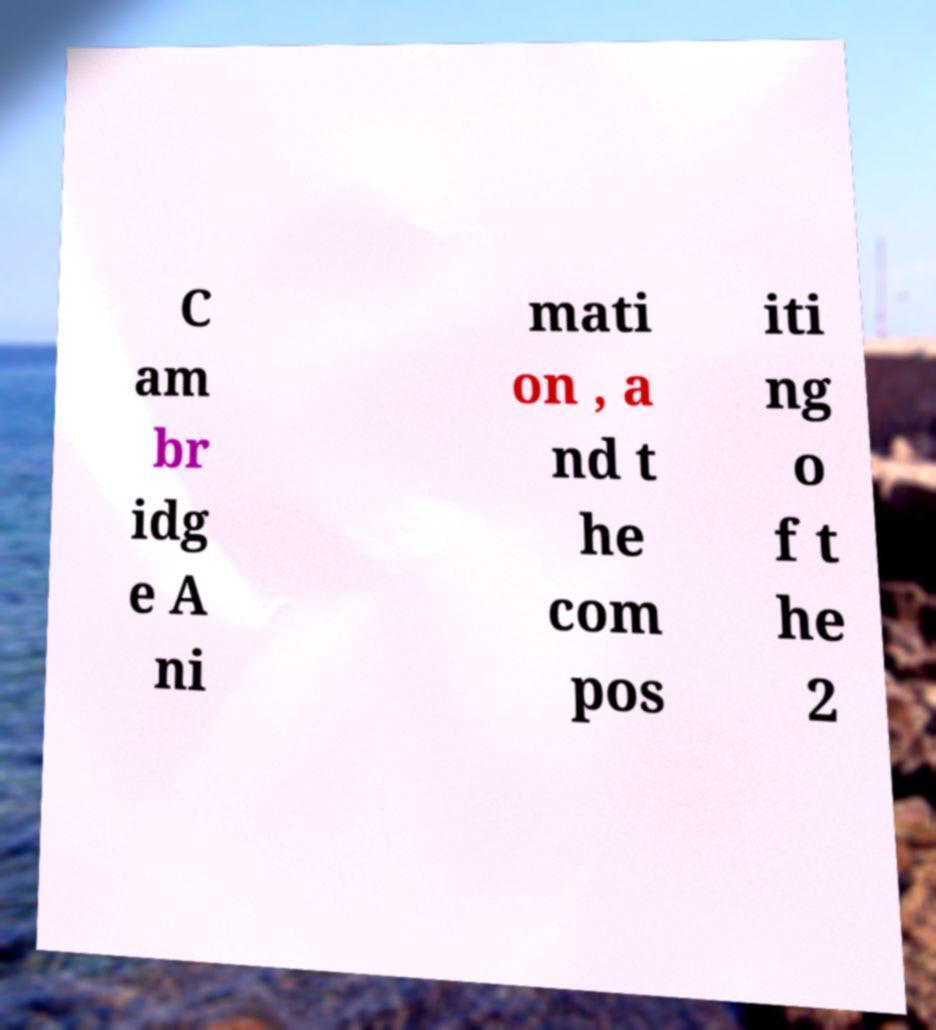I need the written content from this picture converted into text. Can you do that? C am br idg e A ni mati on , a nd t he com pos iti ng o f t he 2 